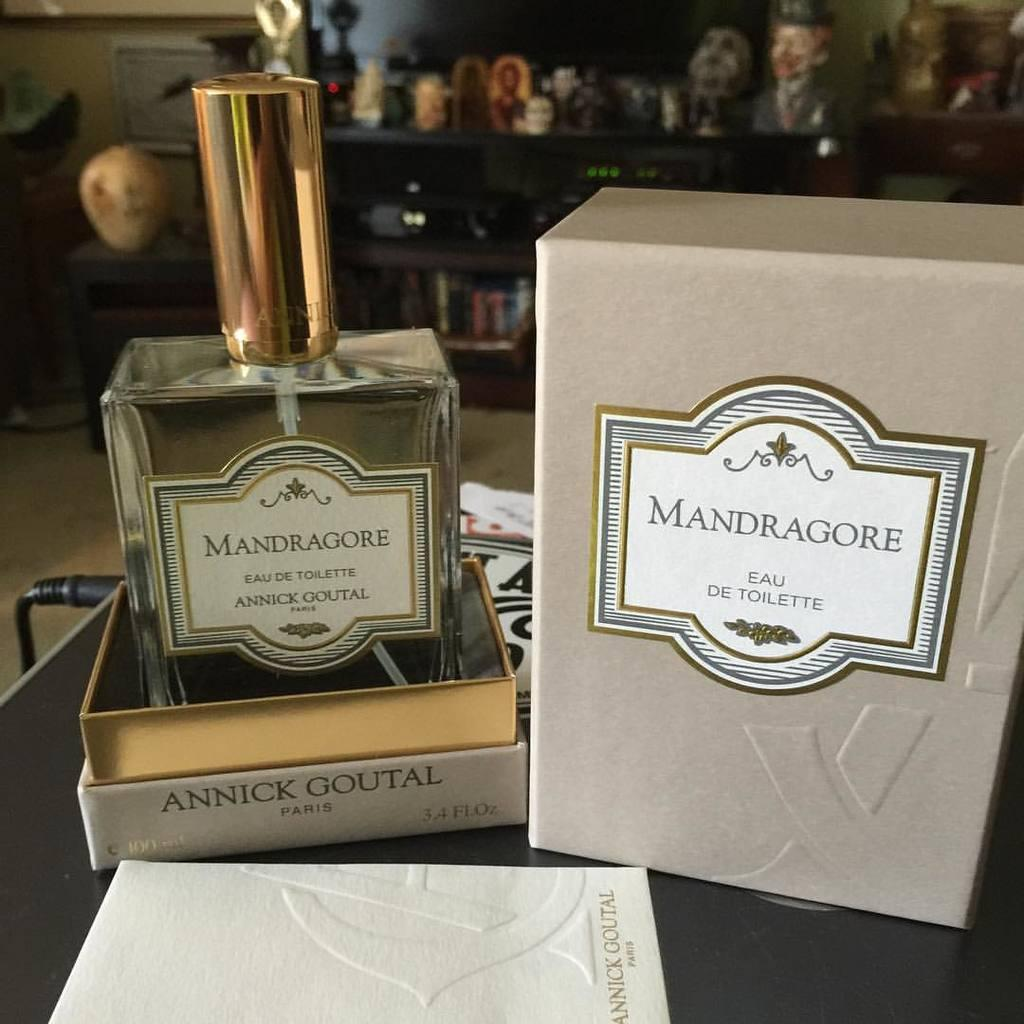<image>
Provide a brief description of the given image. A box of Mandragore Eau De Toilette is open with the bottle of it sitting next to it. 